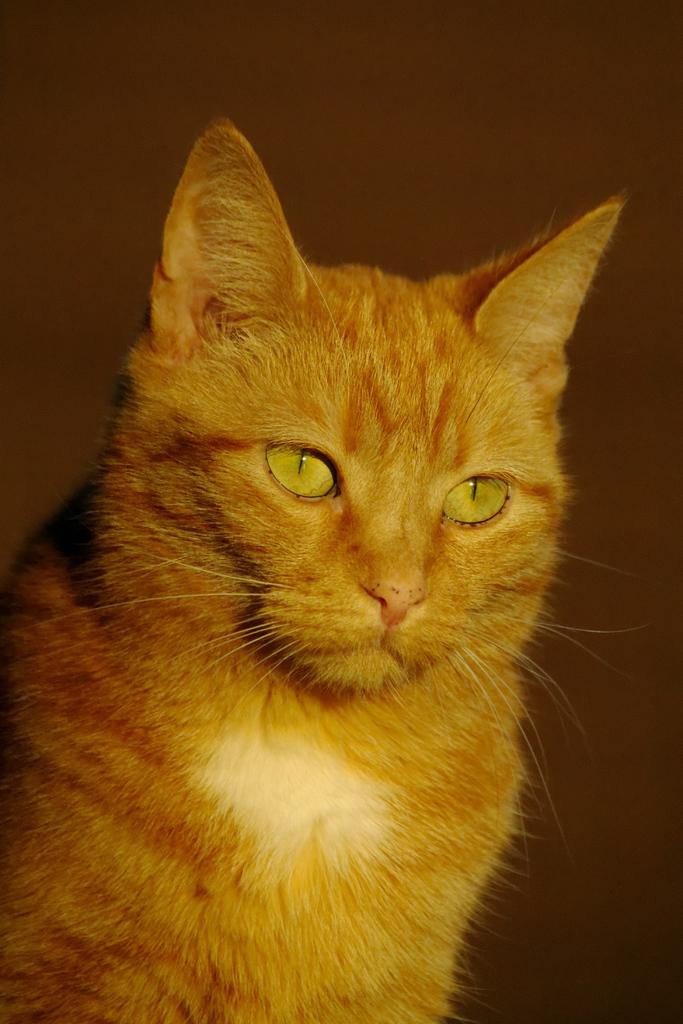What type of animal is in the image? There is a cat in the image. What is behind the cat in the image? There is a wall behind the cat. What song is the cat singing in the image? Cats do not sing songs, so there is no song being sung by the cat in the image. 